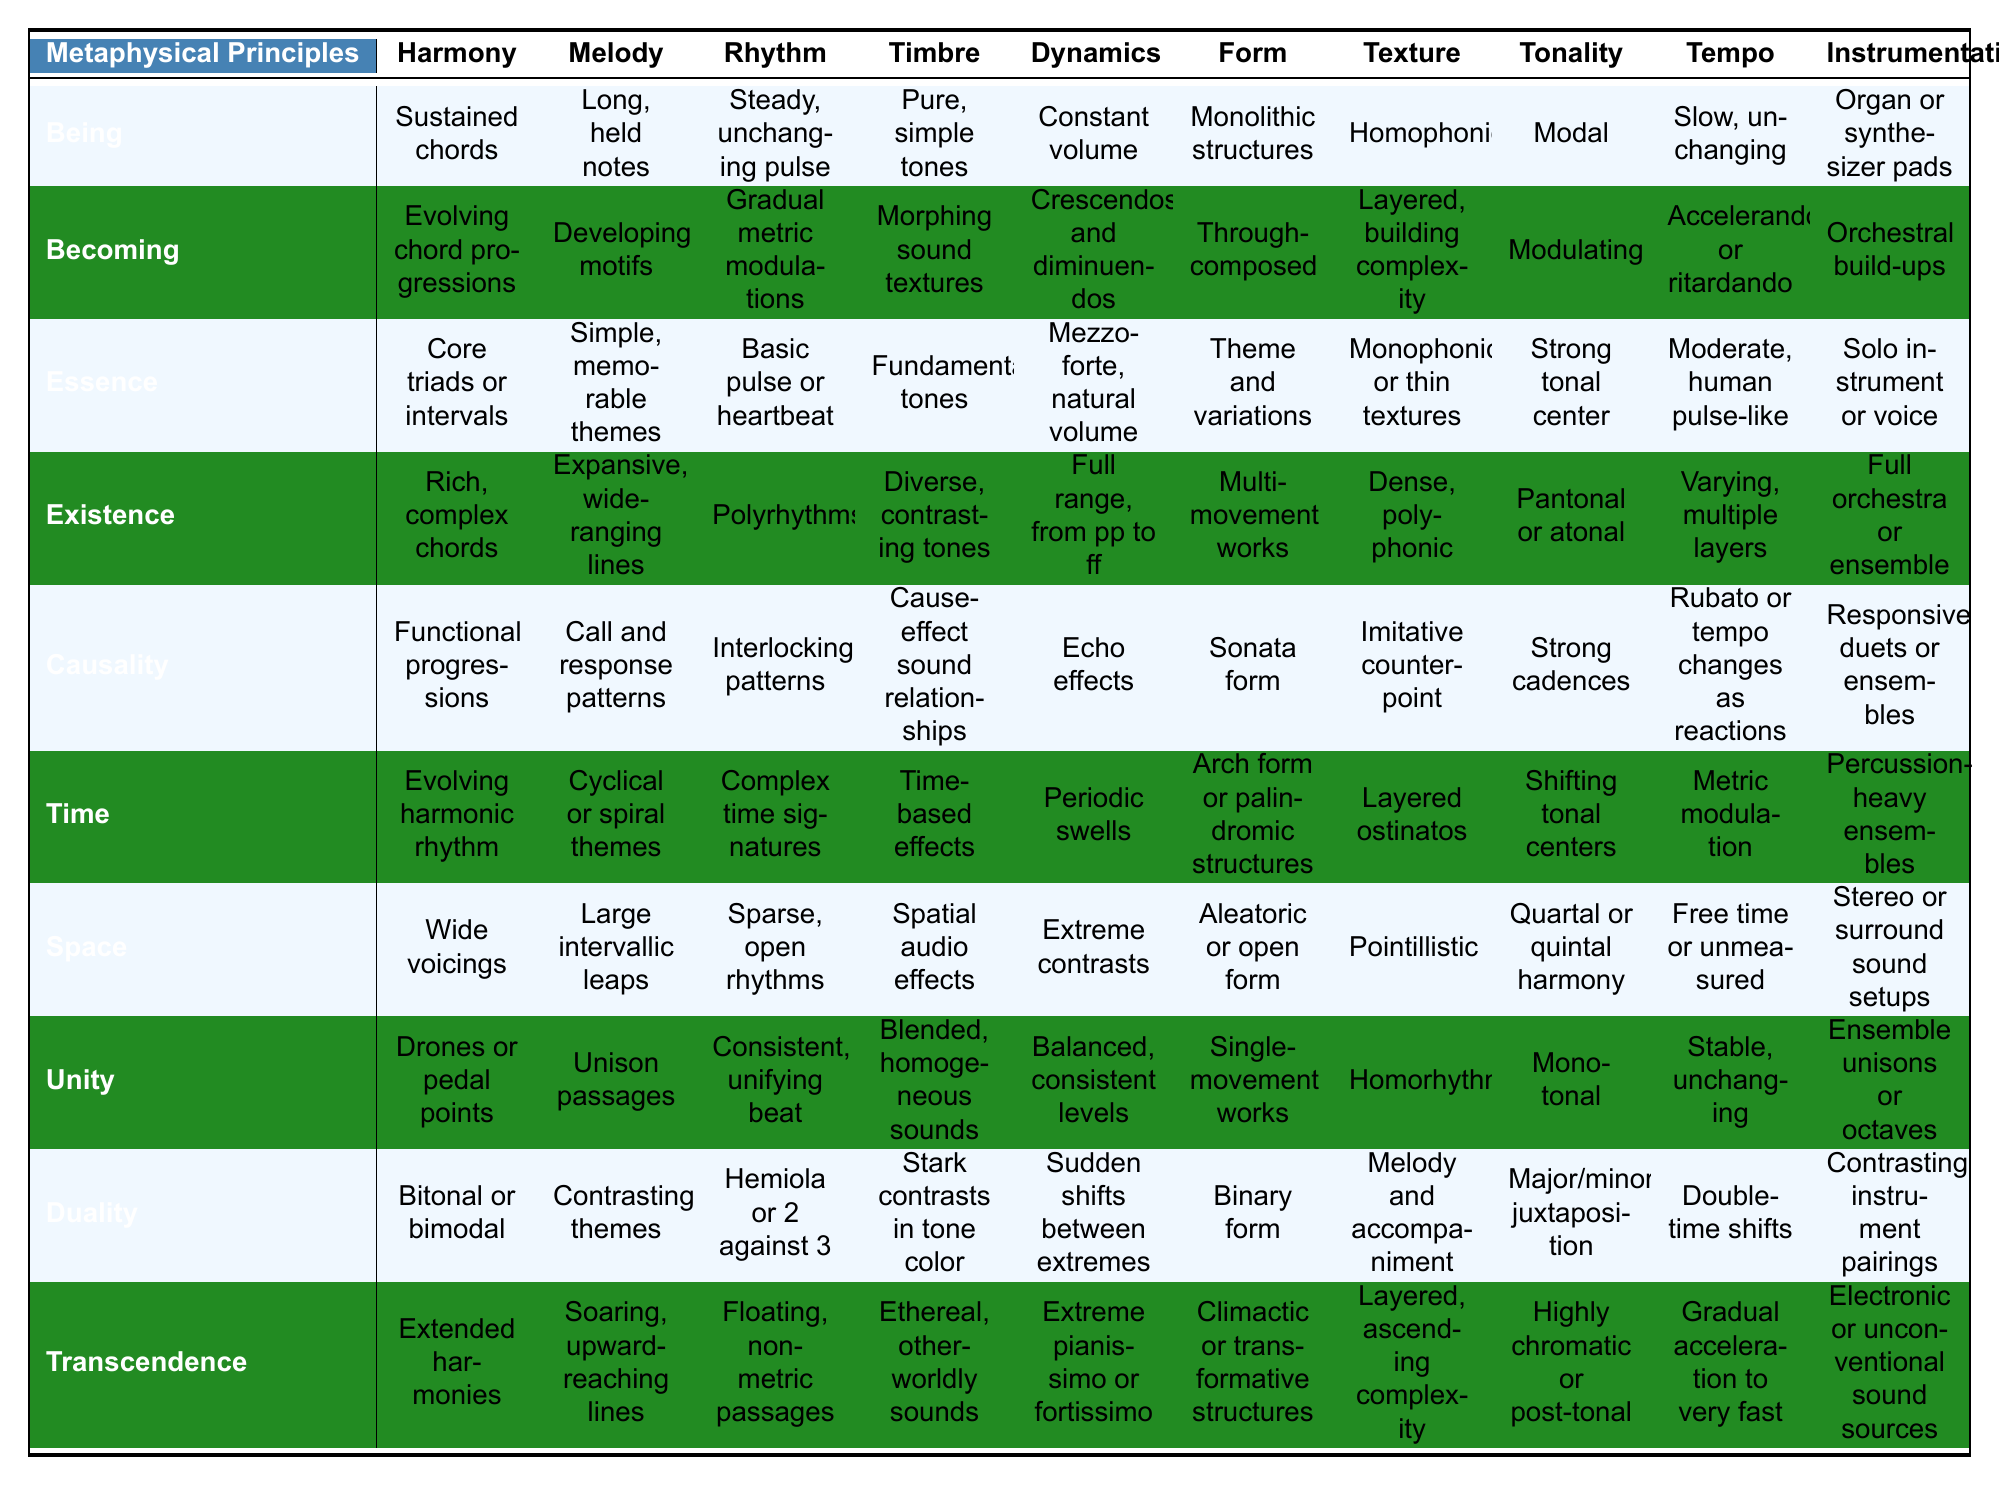What musical element is associated with the principle of "Unity"? To find the musical element related to "Unity," look in the corresponding row for that principle. The table indicates that the element associated with "Unity" is "Drones or pedal points" in harmony.
Answer: Drones or pedal points Which metaphysical principle has the representation of "Cyclic or spiral themes" in melody? The representation of "Cyclical or spiral themes" is found in the "Melody" column under "Time." Thus, the metaphysical principle is "Time."
Answer: Time Does the principle of "Causality" have a complex time signature in rhythm? Upon checking the "Rhythm" column for "Causality," the representation is "Interlocking patterns," not complex time signatures. Thus, the answer is false.
Answer: False Which principle is characterized by "Expansive, wide-ranging lines" in melody? By looking at the "Melody" column for each principle, the one that describes "Expansive, wide-ranging lines" is "Existence."
Answer: Existence What is the difference between the rhythmic representations of "Being" and "Becoming"? "Being" has a "Steady, unchanging pulse" while "Becoming" features "Gradual metric modulations." The difference indicates a shift from static rhythm to dynamic evolution in Becoming.
Answer: Steady vs. Gradual Which metaphysical principle uses "Ethereal, otherworldly sounds" in timbre? Referring to the "Timbre" column, it is clear that "Transcendence" is the principle associated with "Ethereal, otherworldly sounds."
Answer: Transcendence How many metaphysical principles represent "Open rhythms" in rhythm? "Open rhythms" appear in the representation of the principle "Space." Hence, there's only one principle that reflects this characteristic.
Answer: One Which musical element is linked to the principle of "Transcendence" and what does it represent? The table shows that the principle of "Transcendence" is linked to the musical element "Electronic or unconventional sound sources," representing a deviation from traditional sound methods.
Answer: Electronic or unconventional sound sources What similarities exist in the tonalities of "Essence" and "Unity"? Both "Essence" has a "Strong tonal center" while "Unity" is described as "Mono-tonal." The similarity lies in their focus on a singular tonal identity.
Answer: Strong tonal focus in both If we consider dynamics, which principle encapsulates "Full range, from pp to ff"? In the "Dynamics" column, the principle "Existence" is represented by "Full range, from pp to ff," indicating a broad dynamic scope compared to others.
Answer: Existence 